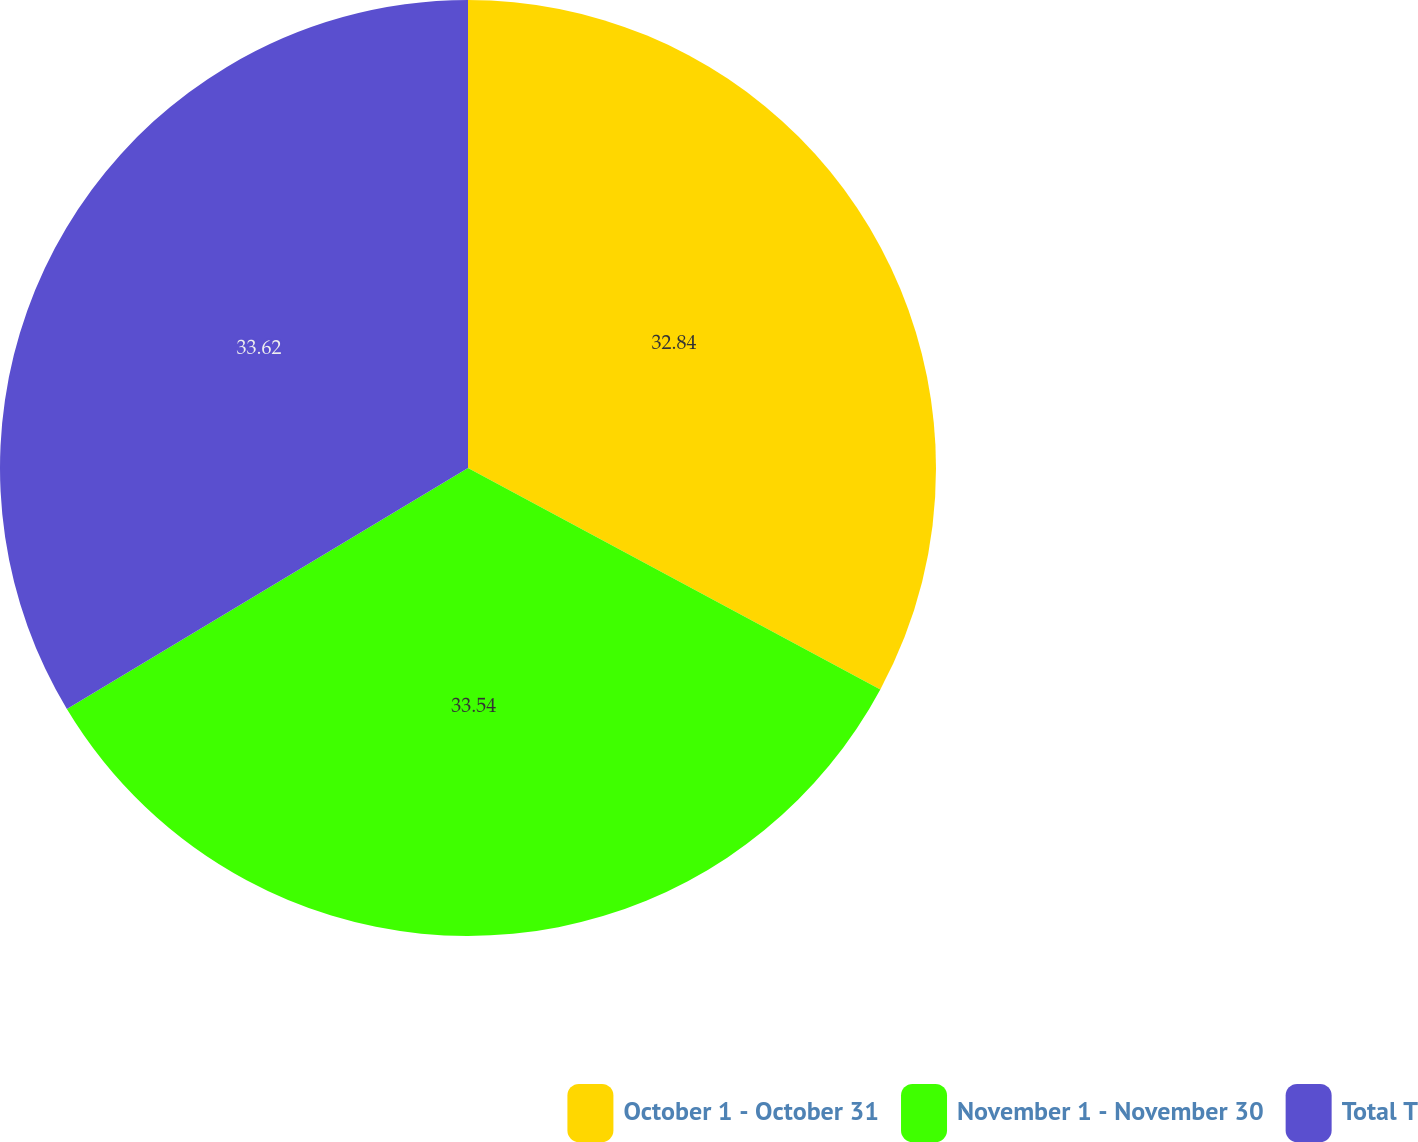Convert chart. <chart><loc_0><loc_0><loc_500><loc_500><pie_chart><fcel>October 1 - October 31<fcel>November 1 - November 30<fcel>Total T<nl><fcel>32.84%<fcel>33.54%<fcel>33.61%<nl></chart> 